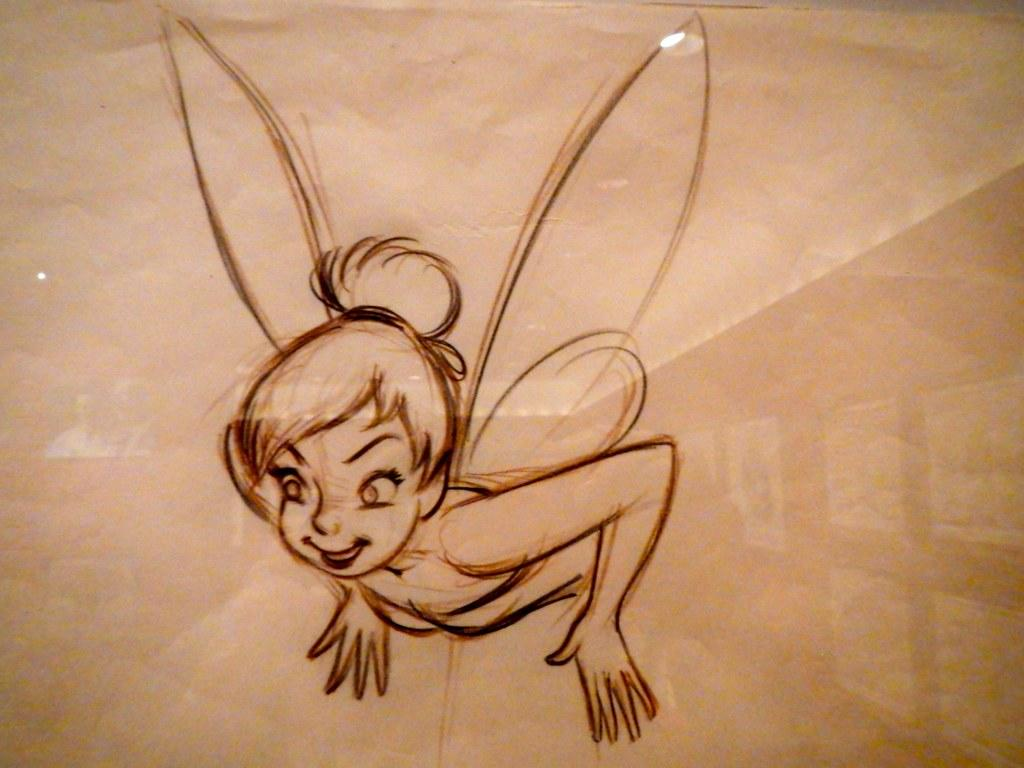What is depicted on the paper in the image? The paper contains a drawing of a girl. What distinguishing feature does the girl in the drawing have? The girl in the drawing has wings. What is the opinion of the girl in the drawing about the property in the image? There is no girl in the image, only a drawing of a girl on the paper. Additionally, the drawing does not depict any property or convey an opinion. 